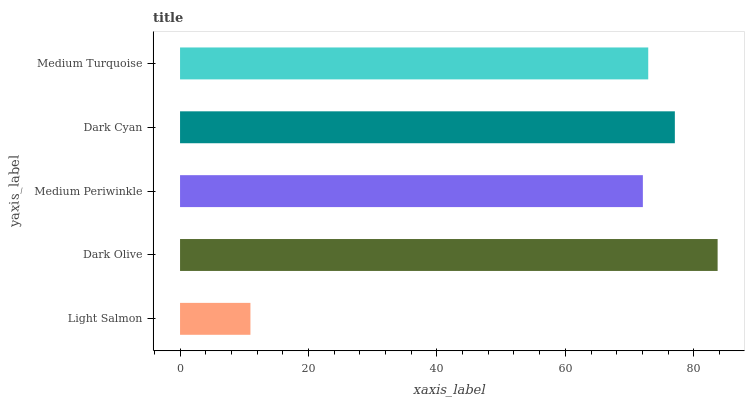Is Light Salmon the minimum?
Answer yes or no. Yes. Is Dark Olive the maximum?
Answer yes or no. Yes. Is Medium Periwinkle the minimum?
Answer yes or no. No. Is Medium Periwinkle the maximum?
Answer yes or no. No. Is Dark Olive greater than Medium Periwinkle?
Answer yes or no. Yes. Is Medium Periwinkle less than Dark Olive?
Answer yes or no. Yes. Is Medium Periwinkle greater than Dark Olive?
Answer yes or no. No. Is Dark Olive less than Medium Periwinkle?
Answer yes or no. No. Is Medium Turquoise the high median?
Answer yes or no. Yes. Is Medium Turquoise the low median?
Answer yes or no. Yes. Is Light Salmon the high median?
Answer yes or no. No. Is Medium Periwinkle the low median?
Answer yes or no. No. 